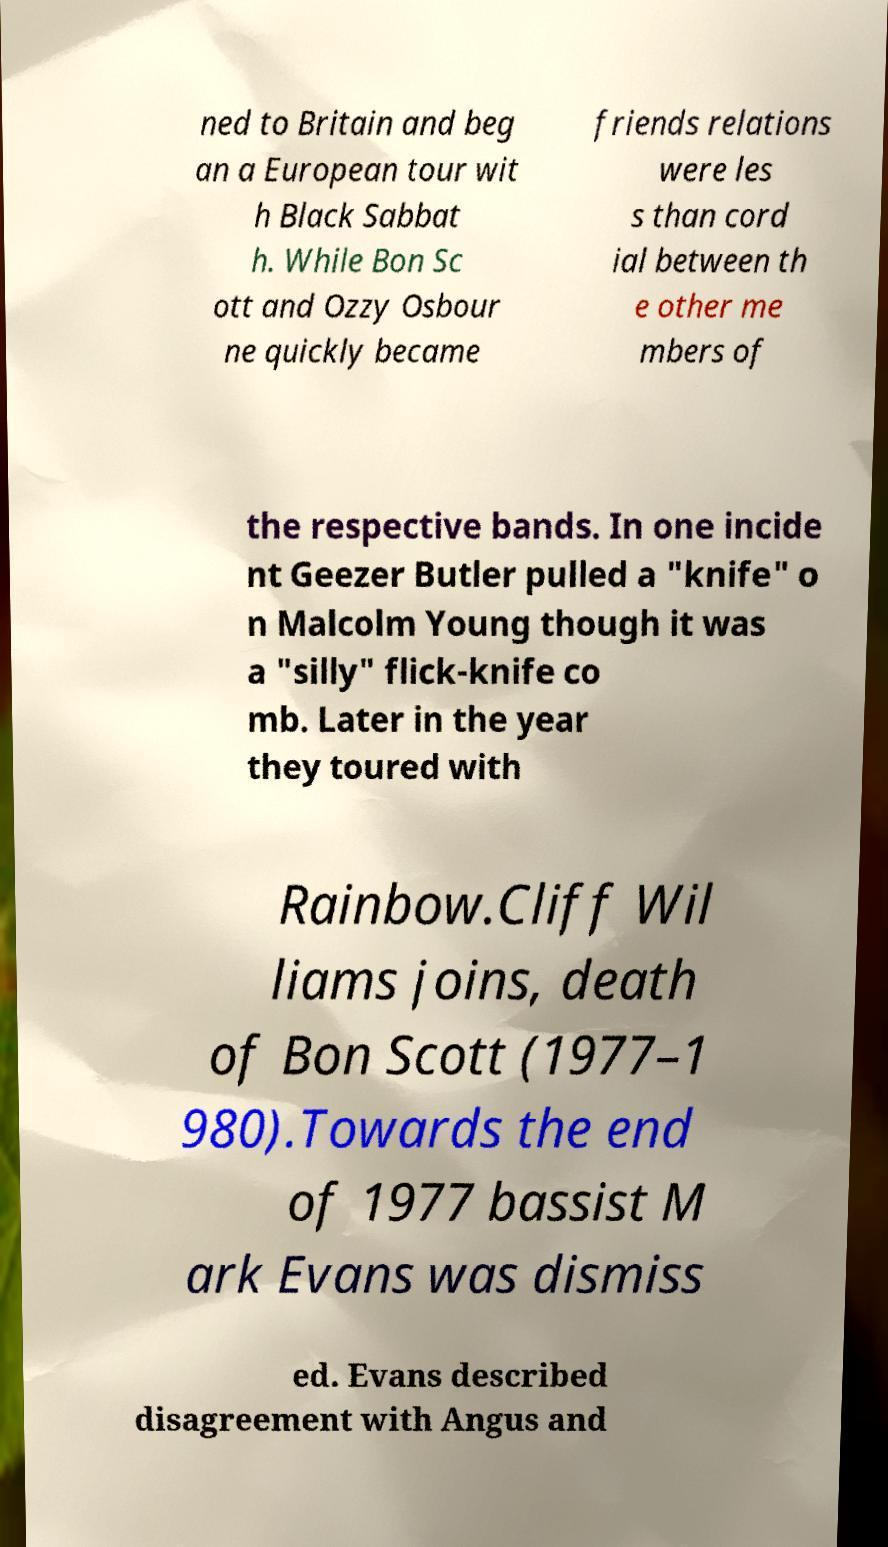Could you extract and type out the text from this image? ned to Britain and beg an a European tour wit h Black Sabbat h. While Bon Sc ott and Ozzy Osbour ne quickly became friends relations were les s than cord ial between th e other me mbers of the respective bands. In one incide nt Geezer Butler pulled a "knife" o n Malcolm Young though it was a "silly" flick-knife co mb. Later in the year they toured with Rainbow.Cliff Wil liams joins, death of Bon Scott (1977–1 980).Towards the end of 1977 bassist M ark Evans was dismiss ed. Evans described disagreement with Angus and 